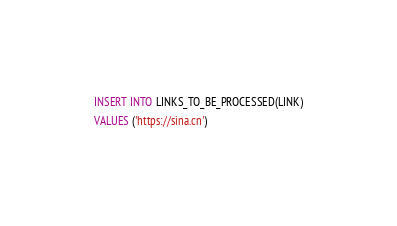<code> <loc_0><loc_0><loc_500><loc_500><_SQL_>INSERT INTO LINKS_TO_BE_PROCESSED(LINK)
VALUES ('https://sina.cn')</code> 